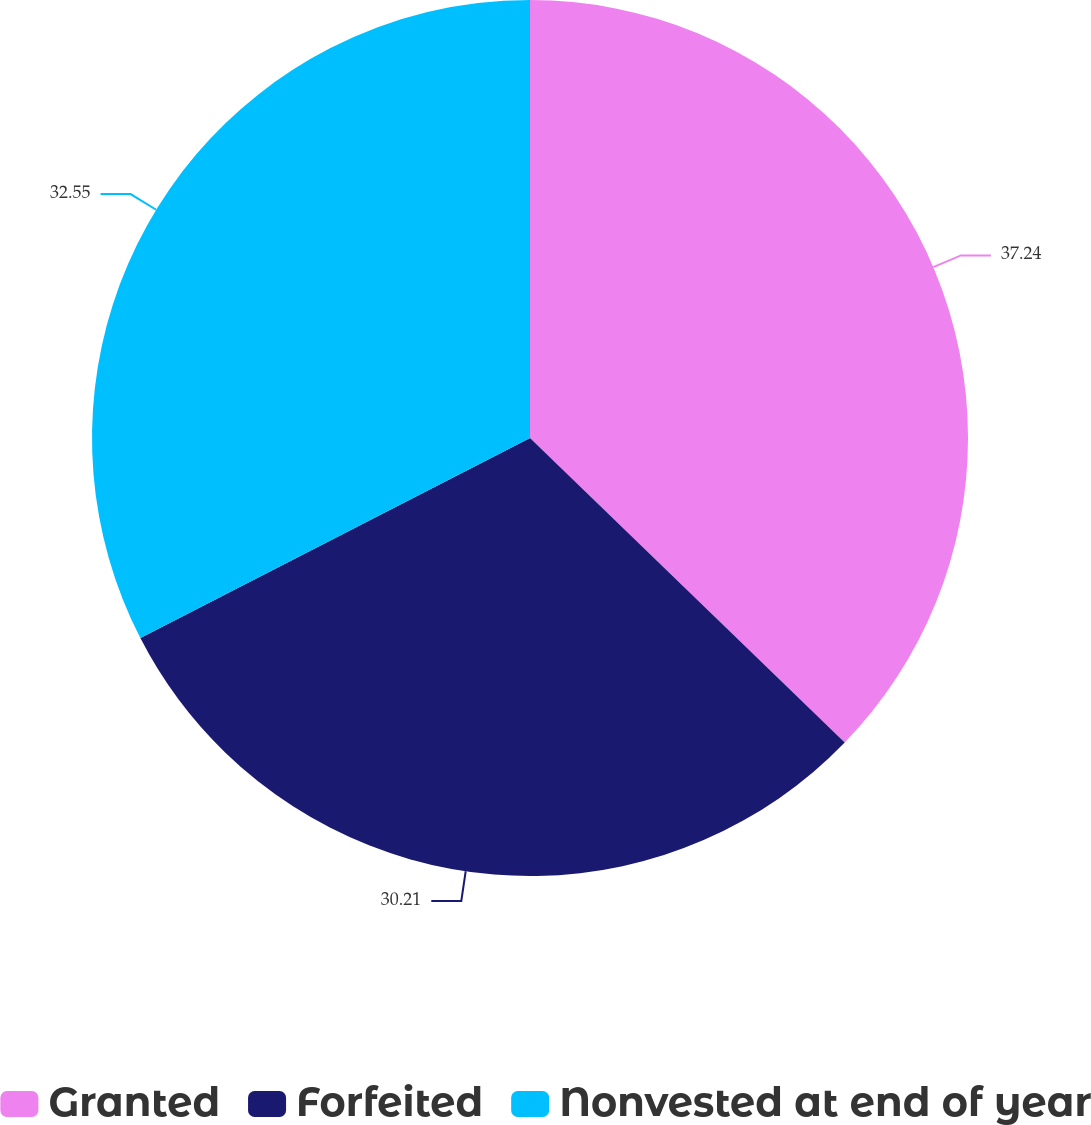<chart> <loc_0><loc_0><loc_500><loc_500><pie_chart><fcel>Granted<fcel>Forfeited<fcel>Nonvested at end of year<nl><fcel>37.24%<fcel>30.21%<fcel>32.55%<nl></chart> 